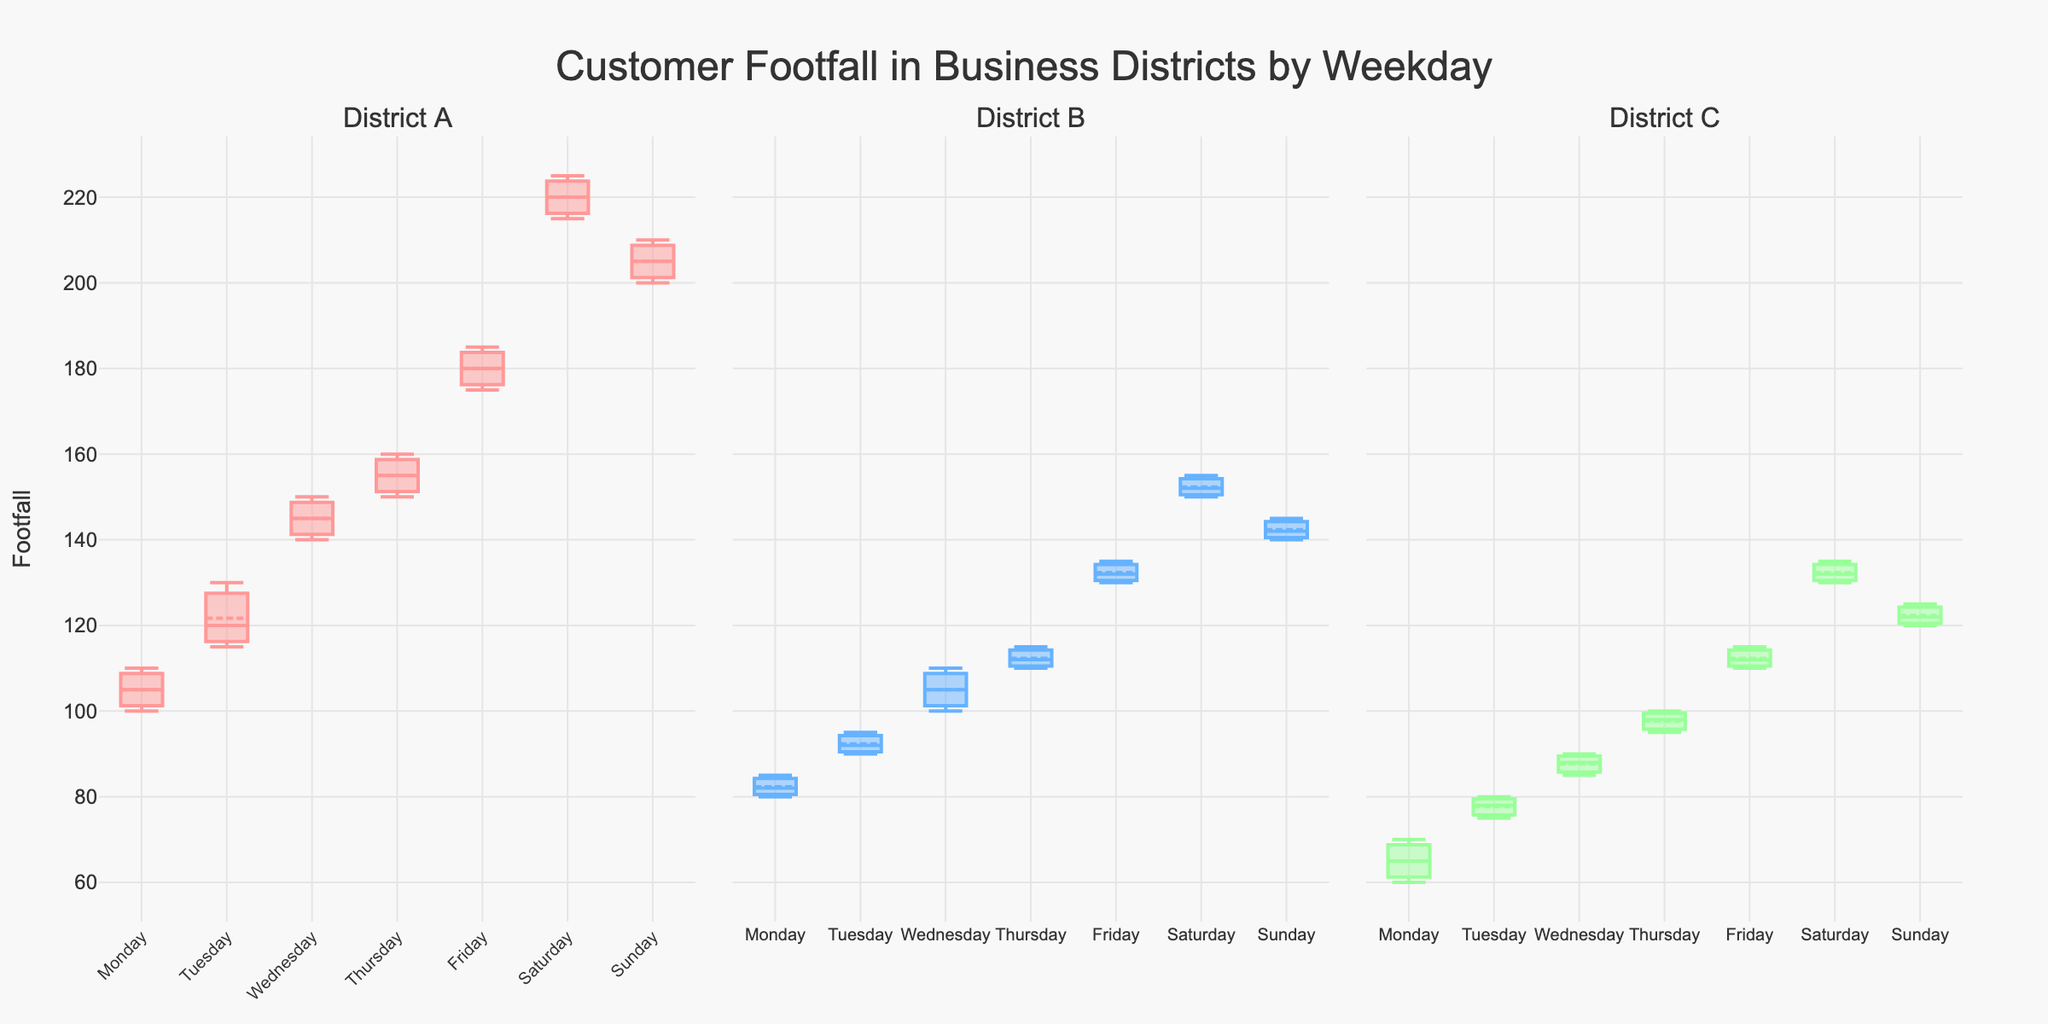How many subplots are there in the figure? The figure contains three subplots, with each subplot representing a different district.
Answer: Three What is the title of the figure? The title of the figure is "Customer Footfall in Business Districts by Weekday", which is displayed at the top center of the plot.
Answer: Customer Footfall in Business Districts by Weekday Which district has the highest median footfall on Saturday? To determine the highest median footfall on Saturday, look at the Saturday box plot for each district and note the median line position. District A's median line is the highest, followed by District B and District C.
Answer: District A Which day has the lowest median footfall in District C? Examine the median lines of the box plots for District C for each day. The lowest median footfall occurs on Monday.
Answer: Monday Compare the median footfall between District A and District B on Friday. Which one is higher? To compare the medians, look at the median lines in the Friday box plots for Districts A and B. District A has a higher median footfall than District B on Friday.
Answer: District A What is the color used for District B's box plot? The color used for District B's box plot is blue. This color differentiation helps in identifying data specific to District B.
Answer: Blue Which District shows the greatest variance in footfall on Sunday? To find the district with the greatest variance, observe the length of the whiskers (range) on Sunday for each district. District A shows the greatest variance on Sunday.
Answer: District A Is the footfall generally higher on weekends compared to weekdays across all districts? Compare the position of the box plots on Saturday and Sunday to those of the weekdays (Monday to Friday) across all districts. The boxes for weekends are generally higher, indicating a higher footfall.
Answer: Yes What is the trend in median footfall for District C throughout the week? Observe the median lines of the box plots for District C from Monday to Sunday. The trend shows an increase in footfall from Monday to Sunday, with peaks at the weekend.
Answer: Increasing 